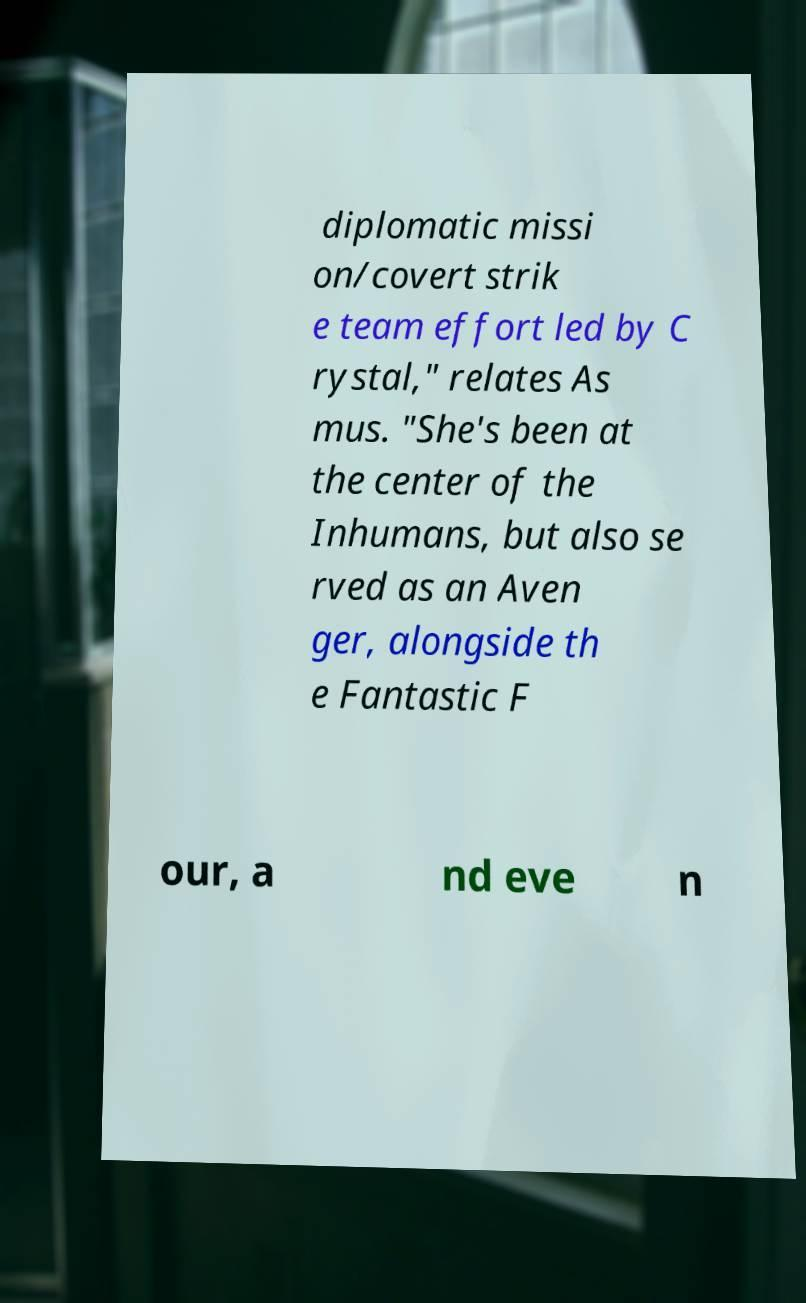What messages or text are displayed in this image? I need them in a readable, typed format. diplomatic missi on/covert strik e team effort led by C rystal," relates As mus. "She's been at the center of the Inhumans, but also se rved as an Aven ger, alongside th e Fantastic F our, a nd eve n 